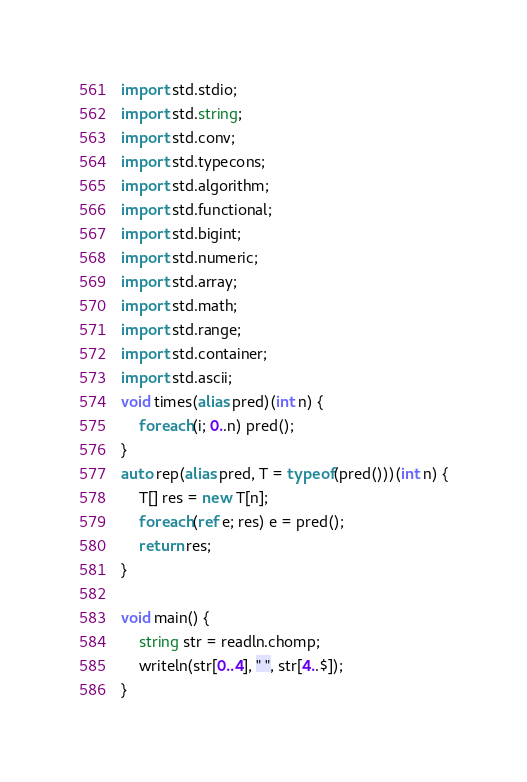Convert code to text. <code><loc_0><loc_0><loc_500><loc_500><_D_>import std.stdio;
import std.string;
import std.conv;
import std.typecons;
import std.algorithm;
import std.functional;
import std.bigint;
import std.numeric;
import std.array;
import std.math;
import std.range;
import std.container;
import std.ascii;
void times(alias pred)(int n) {
    foreach(i; 0..n) pred();
}
auto rep(alias pred, T = typeof(pred()))(int n) {
    T[] res = new T[n];
    foreach(ref e; res) e = pred();
    return res;
}

void main() {
    string str = readln.chomp;
    writeln(str[0..4], " ", str[4..$]);
}
</code> 